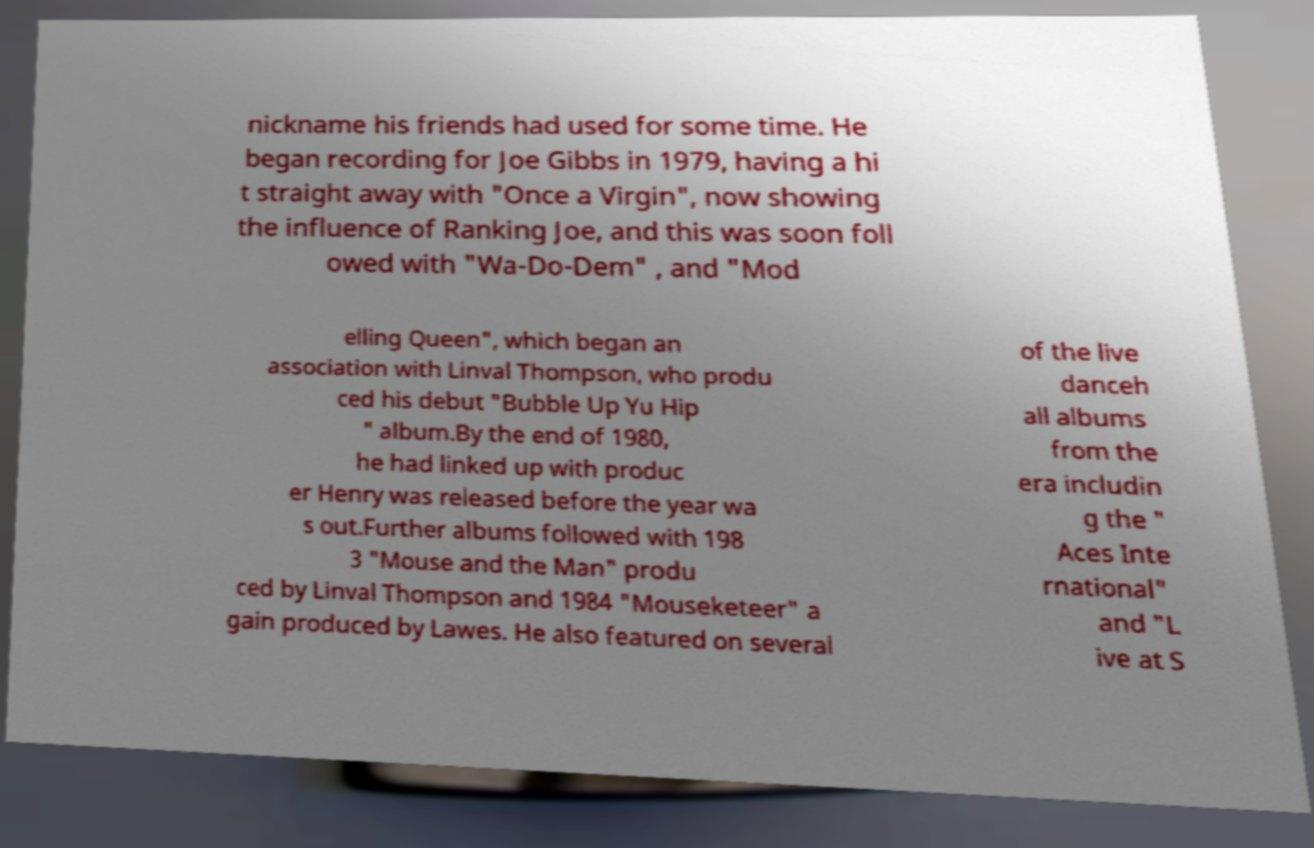For documentation purposes, I need the text within this image transcribed. Could you provide that? nickname his friends had used for some time. He began recording for Joe Gibbs in 1979, having a hi t straight away with "Once a Virgin", now showing the influence of Ranking Joe, and this was soon foll owed with "Wa-Do-Dem" , and "Mod elling Queen", which began an association with Linval Thompson, who produ ced his debut "Bubble Up Yu Hip " album.By the end of 1980, he had linked up with produc er Henry was released before the year wa s out.Further albums followed with 198 3 "Mouse and the Man" produ ced by Linval Thompson and 1984 "Mouseketeer" a gain produced by Lawes. He also featured on several of the live danceh all albums from the era includin g the " Aces Inte rnational" and "L ive at S 